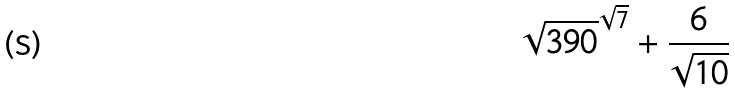<formula> <loc_0><loc_0><loc_500><loc_500>\sqrt { 3 9 0 } ^ { \sqrt { 7 } } + \frac { 6 } { \sqrt { 1 0 } }</formula> 